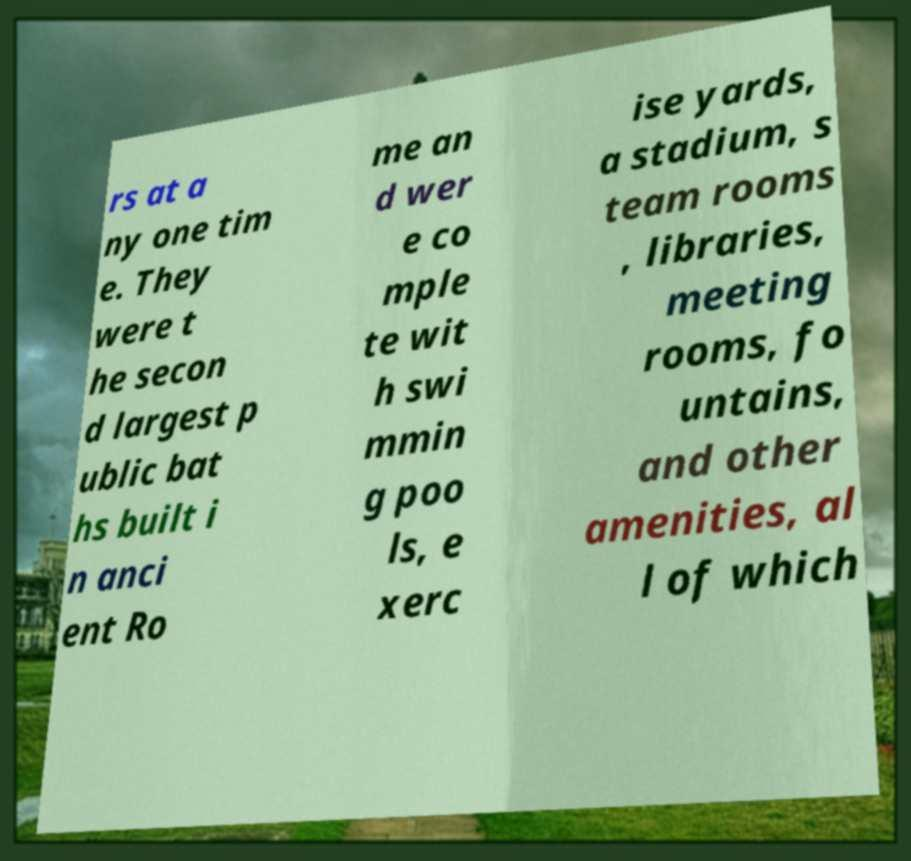Could you assist in decoding the text presented in this image and type it out clearly? rs at a ny one tim e. They were t he secon d largest p ublic bat hs built i n anci ent Ro me an d wer e co mple te wit h swi mmin g poo ls, e xerc ise yards, a stadium, s team rooms , libraries, meeting rooms, fo untains, and other amenities, al l of which 